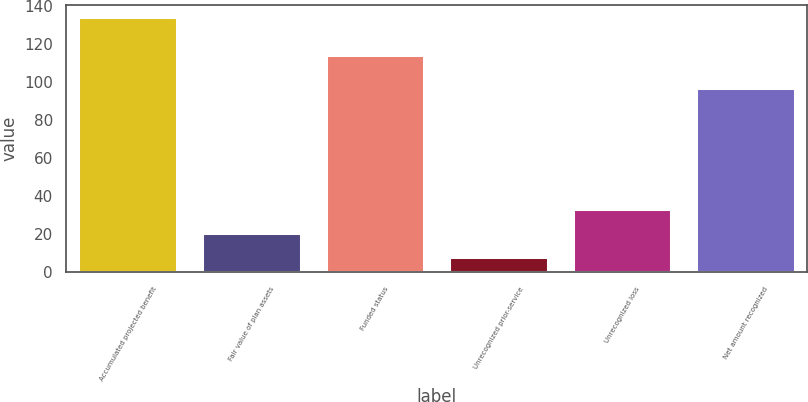Convert chart. <chart><loc_0><loc_0><loc_500><loc_500><bar_chart><fcel>Accumulated projected benefit<fcel>Fair value of plan assets<fcel>Funded status<fcel>Unrecognized prior-service<fcel>Unrecognized loss<fcel>Net amount recognized<nl><fcel>134<fcel>20.6<fcel>114<fcel>8<fcel>33.2<fcel>97<nl></chart> 